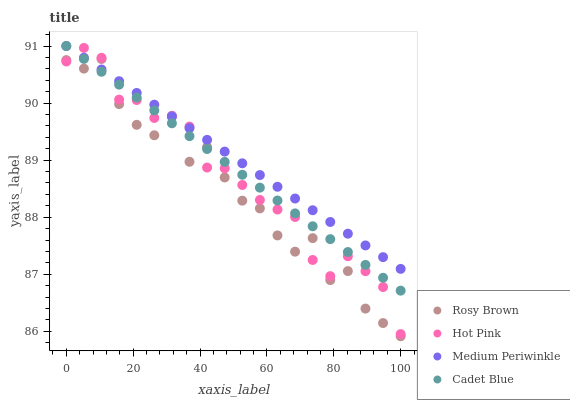Does Rosy Brown have the minimum area under the curve?
Answer yes or no. Yes. Does Medium Periwinkle have the maximum area under the curve?
Answer yes or no. Yes. Does Medium Periwinkle have the minimum area under the curve?
Answer yes or no. No. Does Rosy Brown have the maximum area under the curve?
Answer yes or no. No. Is Medium Periwinkle the smoothest?
Answer yes or no. Yes. Is Rosy Brown the roughest?
Answer yes or no. Yes. Is Rosy Brown the smoothest?
Answer yes or no. No. Is Medium Periwinkle the roughest?
Answer yes or no. No. Does Rosy Brown have the lowest value?
Answer yes or no. Yes. Does Medium Periwinkle have the lowest value?
Answer yes or no. No. Does Medium Periwinkle have the highest value?
Answer yes or no. Yes. Does Rosy Brown have the highest value?
Answer yes or no. No. Does Medium Periwinkle intersect Hot Pink?
Answer yes or no. Yes. Is Medium Periwinkle less than Hot Pink?
Answer yes or no. No. Is Medium Periwinkle greater than Hot Pink?
Answer yes or no. No. 